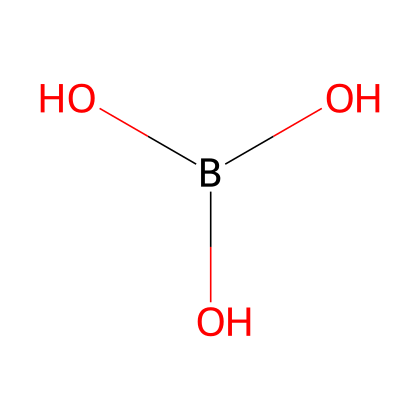What is the name of this chemical? The provided SMILES representation corresponds to boric acid, a compound commonly used in fertilizers. The "B" indicates boron, and the subsequent "(O)(O)O" signifies that it is bonded to three hydroxyl groups.
Answer: boric acid How many oxygen atoms are in the structure? In the structure indicated by the SMILES notation, there are three oxygen atoms attached to the boron atom, as seen in the (O)(O)O grouping.
Answer: three What is the hybridization of the boron atom? The boron atom in this structure has an sp3 hybridization due to the presence of one boron atom bonded to three oxygen atoms, which creates a tetrahedral geometry around boron.
Answer: sp3 Is this compound hypervalent? The compound is defined as hypervalent because the boron atom is bonded to more than the typical number of bonds for its group in the periodic table (which is usually three). Even though boron has only 3 bonds visible, it acts as a central atom that can accept more electrons, which aligns with hypervalency.
Answer: yes What functional groups does the structure have? The structure of boric acid contains three hydroxyl (–OH) functional groups, identified from the three O atoms connected to boron, each forming a hydroxyl group.
Answer: hydroxyl groups What is the primary use of this compound in agriculture? Boric acid is primarily used in agriculture as a micronutrient fertilizer to enhance the growth of plants and ensure healthy crop yields due to its role in cellular processes.
Answer: micronutrient fertilizer 